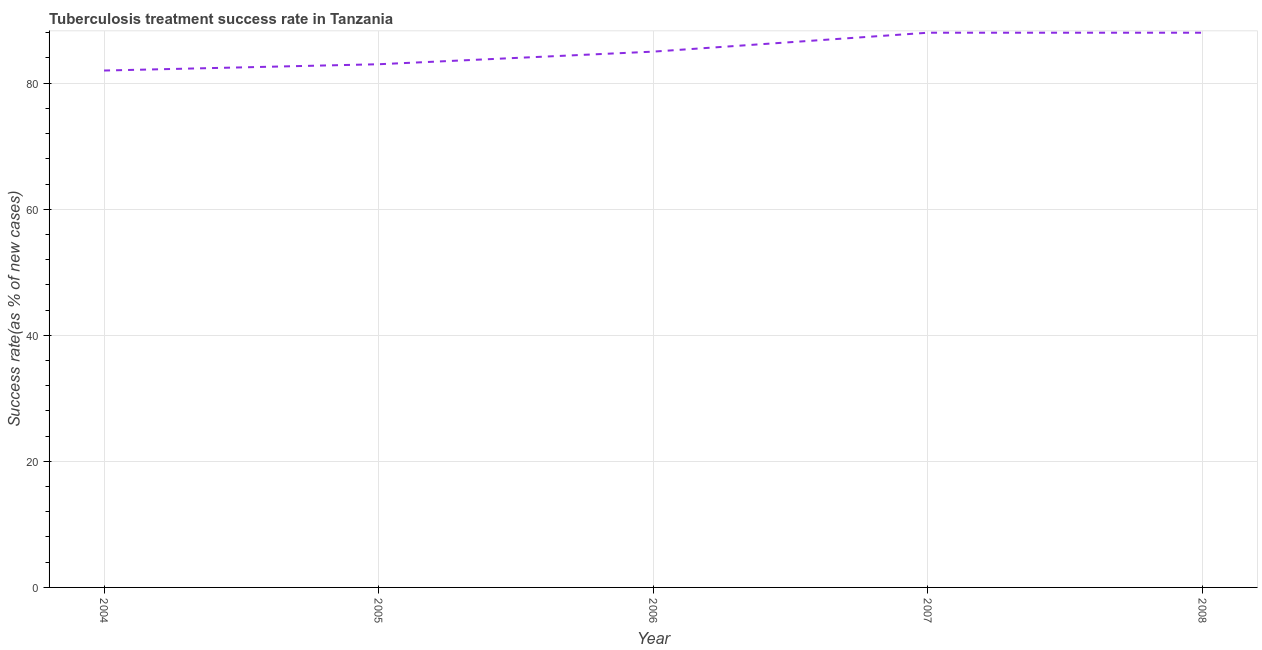What is the tuberculosis treatment success rate in 2005?
Ensure brevity in your answer.  83. Across all years, what is the maximum tuberculosis treatment success rate?
Make the answer very short. 88. Across all years, what is the minimum tuberculosis treatment success rate?
Your answer should be compact. 82. In which year was the tuberculosis treatment success rate minimum?
Provide a succinct answer. 2004. What is the sum of the tuberculosis treatment success rate?
Provide a succinct answer. 426. What is the difference between the tuberculosis treatment success rate in 2005 and 2007?
Keep it short and to the point. -5. What is the average tuberculosis treatment success rate per year?
Provide a short and direct response. 85.2. In how many years, is the tuberculosis treatment success rate greater than 72 %?
Keep it short and to the point. 5. What is the ratio of the tuberculosis treatment success rate in 2006 to that in 2008?
Give a very brief answer. 0.97. Is the tuberculosis treatment success rate in 2004 less than that in 2006?
Make the answer very short. Yes. What is the difference between the highest and the second highest tuberculosis treatment success rate?
Your answer should be compact. 0. Is the sum of the tuberculosis treatment success rate in 2007 and 2008 greater than the maximum tuberculosis treatment success rate across all years?
Make the answer very short. Yes. In how many years, is the tuberculosis treatment success rate greater than the average tuberculosis treatment success rate taken over all years?
Offer a very short reply. 2. Does the tuberculosis treatment success rate monotonically increase over the years?
Give a very brief answer. No. What is the difference between two consecutive major ticks on the Y-axis?
Your answer should be very brief. 20. Are the values on the major ticks of Y-axis written in scientific E-notation?
Make the answer very short. No. Does the graph contain any zero values?
Your answer should be very brief. No. Does the graph contain grids?
Keep it short and to the point. Yes. What is the title of the graph?
Provide a short and direct response. Tuberculosis treatment success rate in Tanzania. What is the label or title of the X-axis?
Offer a very short reply. Year. What is the label or title of the Y-axis?
Your answer should be compact. Success rate(as % of new cases). What is the Success rate(as % of new cases) of 2005?
Your answer should be compact. 83. What is the Success rate(as % of new cases) in 2007?
Offer a very short reply. 88. What is the difference between the Success rate(as % of new cases) in 2004 and 2007?
Your answer should be compact. -6. What is the difference between the Success rate(as % of new cases) in 2004 and 2008?
Provide a succinct answer. -6. What is the difference between the Success rate(as % of new cases) in 2005 and 2006?
Your response must be concise. -2. What is the difference between the Success rate(as % of new cases) in 2005 and 2008?
Provide a succinct answer. -5. What is the difference between the Success rate(as % of new cases) in 2006 and 2007?
Offer a terse response. -3. What is the difference between the Success rate(as % of new cases) in 2006 and 2008?
Your answer should be very brief. -3. What is the ratio of the Success rate(as % of new cases) in 2004 to that in 2005?
Provide a short and direct response. 0.99. What is the ratio of the Success rate(as % of new cases) in 2004 to that in 2006?
Make the answer very short. 0.96. What is the ratio of the Success rate(as % of new cases) in 2004 to that in 2007?
Provide a short and direct response. 0.93. What is the ratio of the Success rate(as % of new cases) in 2004 to that in 2008?
Keep it short and to the point. 0.93. What is the ratio of the Success rate(as % of new cases) in 2005 to that in 2006?
Provide a succinct answer. 0.98. What is the ratio of the Success rate(as % of new cases) in 2005 to that in 2007?
Give a very brief answer. 0.94. What is the ratio of the Success rate(as % of new cases) in 2005 to that in 2008?
Provide a short and direct response. 0.94. What is the ratio of the Success rate(as % of new cases) in 2006 to that in 2008?
Make the answer very short. 0.97. 